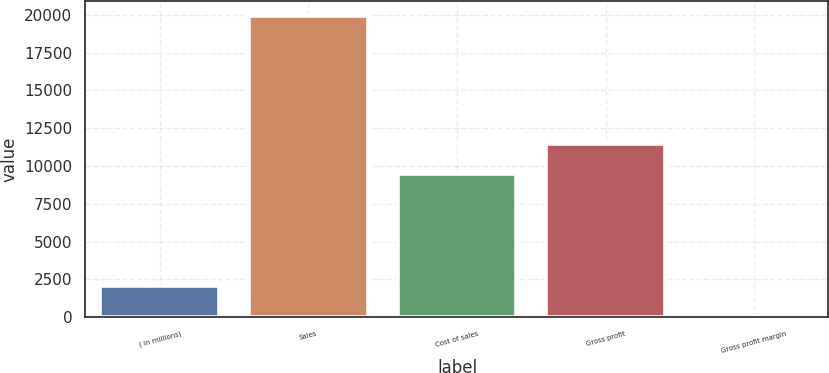Convert chart. <chart><loc_0><loc_0><loc_500><loc_500><bar_chart><fcel>( in millions)<fcel>Sales<fcel>Cost of sales<fcel>Gross profit<fcel>Gross profit margin<nl><fcel>2038.54<fcel>19913.8<fcel>9471.3<fcel>11457.4<fcel>52.4<nl></chart> 